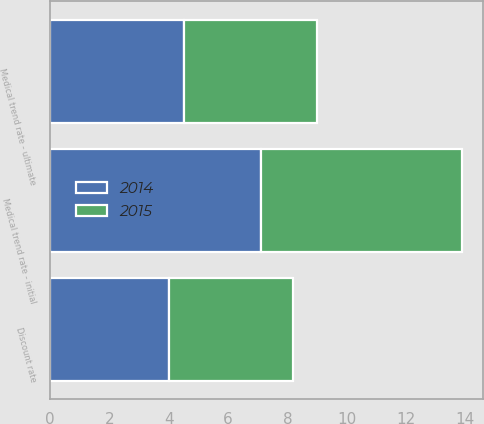Convert chart. <chart><loc_0><loc_0><loc_500><loc_500><stacked_bar_chart><ecel><fcel>Discount rate<fcel>Medical trend rate - initial<fcel>Medical trend rate - ultimate<nl><fcel>2015<fcel>4.2<fcel>6.8<fcel>4.5<nl><fcel>2014<fcel>4<fcel>7.1<fcel>4.5<nl></chart> 